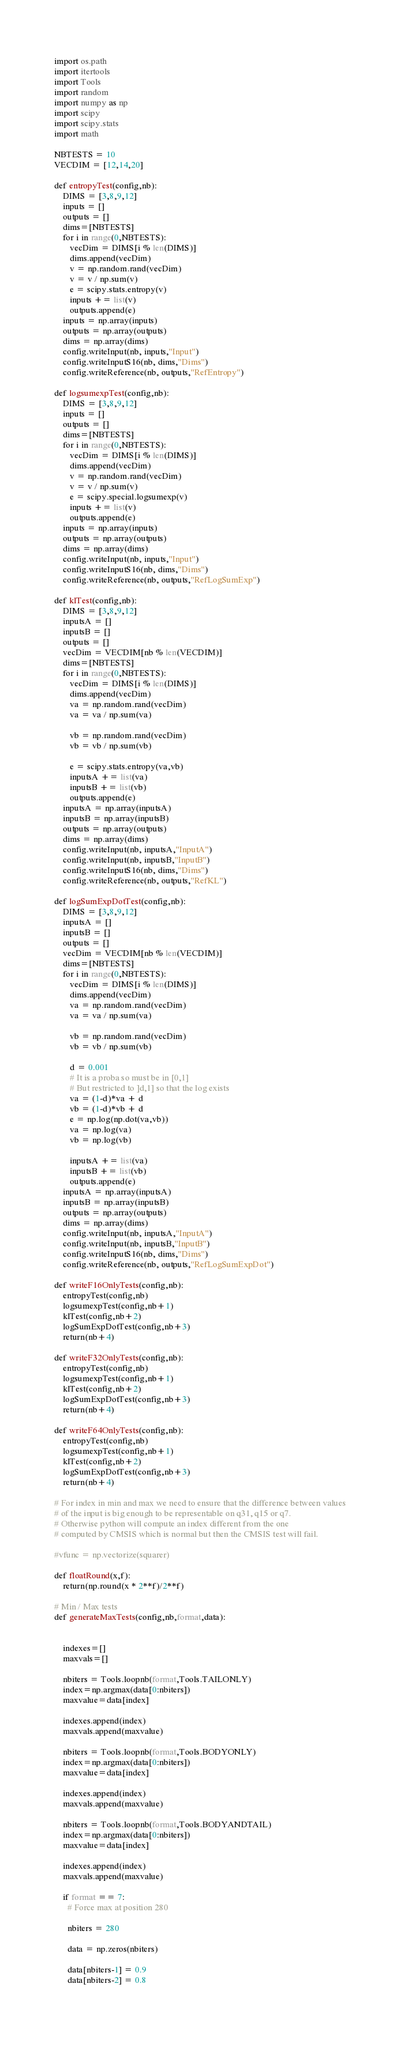<code> <loc_0><loc_0><loc_500><loc_500><_Python_>import os.path
import itertools
import Tools
import random
import numpy as np
import scipy
import scipy.stats
import math

NBTESTS = 10
VECDIM = [12,14,20]

def entropyTest(config,nb):
    DIMS = [3,8,9,12]
    inputs = [] 
    outputs = [] 
    dims=[NBTESTS]
    for i in range(0,NBTESTS):
       vecDim = DIMS[i % len(DIMS)]
       dims.append(vecDim)
       v = np.random.rand(vecDim)
       v = v / np.sum(v)
       e = scipy.stats.entropy(v)
       inputs += list(v)
       outputs.append(e)
    inputs = np.array(inputs)
    outputs = np.array(outputs)
    dims = np.array(dims)
    config.writeInput(nb, inputs,"Input")
    config.writeInputS16(nb, dims,"Dims")
    config.writeReference(nb, outputs,"RefEntropy")

def logsumexpTest(config,nb):
    DIMS = [3,8,9,12]
    inputs = [] 
    outputs = [] 
    dims=[NBTESTS]
    for i in range(0,NBTESTS):
       vecDim = DIMS[i % len(DIMS)]
       dims.append(vecDim)
       v = np.random.rand(vecDim)
       v = v / np.sum(v)
       e = scipy.special.logsumexp(v)
       inputs += list(v)
       outputs.append(e)
    inputs = np.array(inputs)
    outputs = np.array(outputs)
    dims = np.array(dims)
    config.writeInput(nb, inputs,"Input")
    config.writeInputS16(nb, dims,"Dims")
    config.writeReference(nb, outputs,"RefLogSumExp")

def klTest(config,nb):
    DIMS = [3,8,9,12]
    inputsA = [] 
    inputsB = [] 
    outputs = [] 
    vecDim = VECDIM[nb % len(VECDIM)]
    dims=[NBTESTS]
    for i in range(0,NBTESTS):
       vecDim = DIMS[i % len(DIMS)]
       dims.append(vecDim)
       va = np.random.rand(vecDim)
       va = va / np.sum(va)

       vb = np.random.rand(vecDim)
       vb = vb / np.sum(vb)

       e = scipy.stats.entropy(va,vb)
       inputsA += list(va)
       inputsB += list(vb)
       outputs.append(e)
    inputsA = np.array(inputsA)
    inputsB = np.array(inputsB)
    outputs = np.array(outputs)
    dims = np.array(dims)
    config.writeInput(nb, inputsA,"InputA")
    config.writeInput(nb, inputsB,"InputB")
    config.writeInputS16(nb, dims,"Dims")
    config.writeReference(nb, outputs,"RefKL")

def logSumExpDotTest(config,nb):
    DIMS = [3,8,9,12]
    inputsA = [] 
    inputsB = [] 
    outputs = [] 
    vecDim = VECDIM[nb % len(VECDIM)]
    dims=[NBTESTS]
    for i in range(0,NBTESTS):
       vecDim = DIMS[i % len(DIMS)]
       dims.append(vecDim)
       va = np.random.rand(vecDim)
       va = va / np.sum(va)

       vb = np.random.rand(vecDim)
       vb = vb / np.sum(vb)

       d = 0.001
       # It is a proba so must be in [0,1]
       # But restricted to ]d,1] so that the log exists
       va = (1-d)*va + d
       vb = (1-d)*vb + d
       e = np.log(np.dot(va,vb))
       va = np.log(va)
       vb = np.log(vb)

       inputsA += list(va)
       inputsB += list(vb)
       outputs.append(e)
    inputsA = np.array(inputsA)
    inputsB = np.array(inputsB)
    outputs = np.array(outputs)
    dims = np.array(dims)
    config.writeInput(nb, inputsA,"InputA")
    config.writeInput(nb, inputsB,"InputB")
    config.writeInputS16(nb, dims,"Dims")
    config.writeReference(nb, outputs,"RefLogSumExpDot")

def writeF16OnlyTests(config,nb):
    entropyTest(config,nb)
    logsumexpTest(config,nb+1)
    klTest(config,nb+2)
    logSumExpDotTest(config,nb+3)
    return(nb+4)

def writeF32OnlyTests(config,nb):
    entropyTest(config,nb)
    logsumexpTest(config,nb+1)
    klTest(config,nb+2)
    logSumExpDotTest(config,nb+3)
    return(nb+4)

def writeF64OnlyTests(config,nb):
    entropyTest(config,nb)
    logsumexpTest(config,nb+1)
    klTest(config,nb+2)
    logSumExpDotTest(config,nb+3)
    return(nb+4)

# For index in min and max we need to ensure that the difference between values
# of the input is big enough to be representable on q31, q15 or q7.
# Otherwise python will compute an index different from the one
# computed by CMSIS which is normal but then the CMSIS test will fail.

#vfunc = np.vectorize(squarer)

def floatRound(x,f):
    return(np.round(x * 2**f)/2**f)

# Min / Max tests
def generateMaxTests(config,nb,format,data):

    
    indexes=[]
    maxvals=[]

    nbiters = Tools.loopnb(format,Tools.TAILONLY)
    index=np.argmax(data[0:nbiters])
    maxvalue=data[index]

    indexes.append(index)
    maxvals.append(maxvalue)

    nbiters = Tools.loopnb(format,Tools.BODYONLY)
    index=np.argmax(data[0:nbiters])
    maxvalue=data[index]

    indexes.append(index)
    maxvals.append(maxvalue)

    nbiters = Tools.loopnb(format,Tools.BODYANDTAIL)
    index=np.argmax(data[0:nbiters])
    maxvalue=data[index]

    indexes.append(index)
    maxvals.append(maxvalue)

    if format == 7:
      # Force max at position 280
  
      nbiters = 280
  
      data = np.zeros(nbiters)
  
      data[nbiters-1] = 0.9 
      data[nbiters-2] = 0.8 
  </code> 